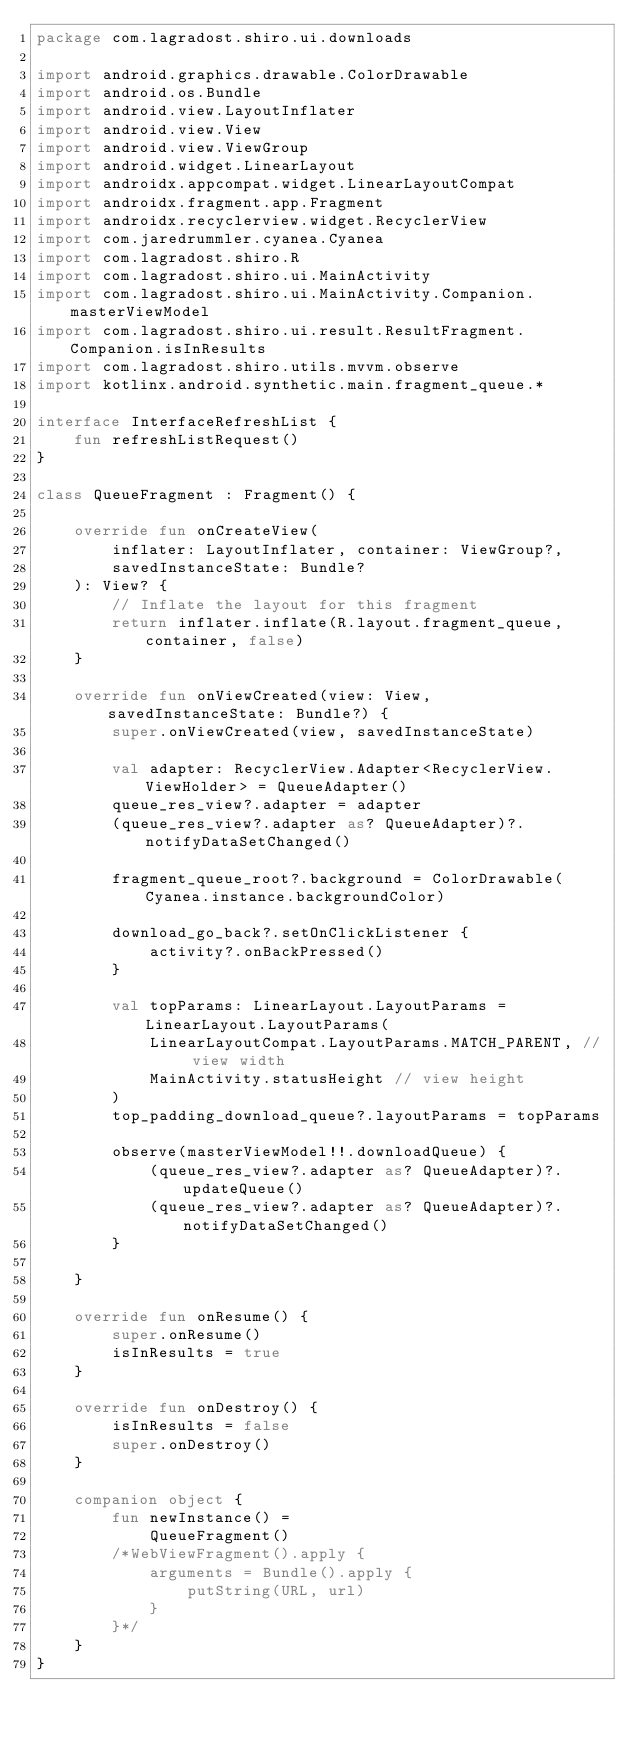Convert code to text. <code><loc_0><loc_0><loc_500><loc_500><_Kotlin_>package com.lagradost.shiro.ui.downloads

import android.graphics.drawable.ColorDrawable
import android.os.Bundle
import android.view.LayoutInflater
import android.view.View
import android.view.ViewGroup
import android.widget.LinearLayout
import androidx.appcompat.widget.LinearLayoutCompat
import androidx.fragment.app.Fragment
import androidx.recyclerview.widget.RecyclerView
import com.jaredrummler.cyanea.Cyanea
import com.lagradost.shiro.R
import com.lagradost.shiro.ui.MainActivity
import com.lagradost.shiro.ui.MainActivity.Companion.masterViewModel
import com.lagradost.shiro.ui.result.ResultFragment.Companion.isInResults
import com.lagradost.shiro.utils.mvvm.observe
import kotlinx.android.synthetic.main.fragment_queue.*

interface InterfaceRefreshList {
    fun refreshListRequest()
}

class QueueFragment : Fragment() {

    override fun onCreateView(
        inflater: LayoutInflater, container: ViewGroup?,
        savedInstanceState: Bundle?
    ): View? {
        // Inflate the layout for this fragment
        return inflater.inflate(R.layout.fragment_queue, container, false)
    }

    override fun onViewCreated(view: View, savedInstanceState: Bundle?) {
        super.onViewCreated(view, savedInstanceState)

        val adapter: RecyclerView.Adapter<RecyclerView.ViewHolder> = QueueAdapter()
        queue_res_view?.adapter = adapter
        (queue_res_view?.adapter as? QueueAdapter)?.notifyDataSetChanged()

        fragment_queue_root?.background = ColorDrawable(Cyanea.instance.backgroundColor)

        download_go_back?.setOnClickListener {
            activity?.onBackPressed()
        }

        val topParams: LinearLayout.LayoutParams = LinearLayout.LayoutParams(
            LinearLayoutCompat.LayoutParams.MATCH_PARENT, // view width
            MainActivity.statusHeight // view height
        )
        top_padding_download_queue?.layoutParams = topParams

        observe(masterViewModel!!.downloadQueue) {
            (queue_res_view?.adapter as? QueueAdapter)?.updateQueue()
            (queue_res_view?.adapter as? QueueAdapter)?.notifyDataSetChanged()
        }

    }

    override fun onResume() {
        super.onResume()
        isInResults = true
    }

    override fun onDestroy() {
        isInResults = false
        super.onDestroy()
    }

    companion object {
        fun newInstance() =
            QueueFragment()
        /*WebViewFragment().apply {
            arguments = Bundle().apply {
                putString(URL, url)
            }
        }*/
    }
}</code> 